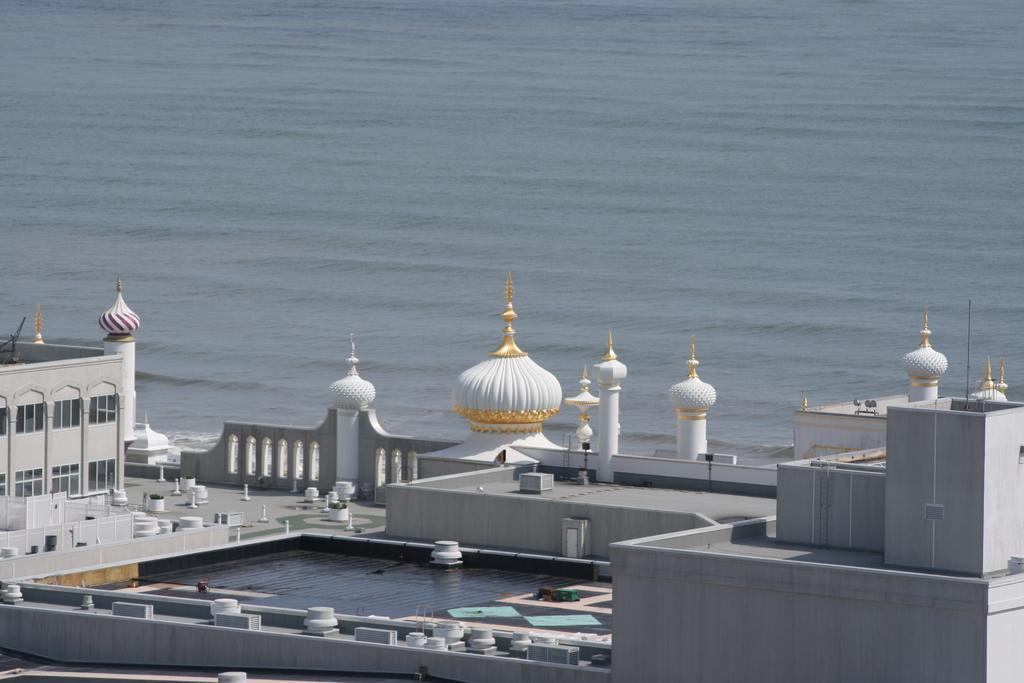Can you describe this image briefly? In the image there is a mosque floating on the water surface. 